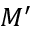<formula> <loc_0><loc_0><loc_500><loc_500>M ^ { \prime }</formula> 